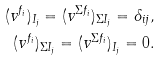Convert formula to latex. <formula><loc_0><loc_0><loc_500><loc_500>( v ^ { f _ { i } } ) _ { I _ { j } } = ( v ^ { \Sigma f _ { i } } ) _ { \Sigma I _ { j } } = \delta _ { i j } , \\ ( v ^ { f _ { i } } ) _ { \Sigma I _ { j } } = ( v ^ { \Sigma f _ { i } } ) _ { I _ { j } } = 0 .</formula> 